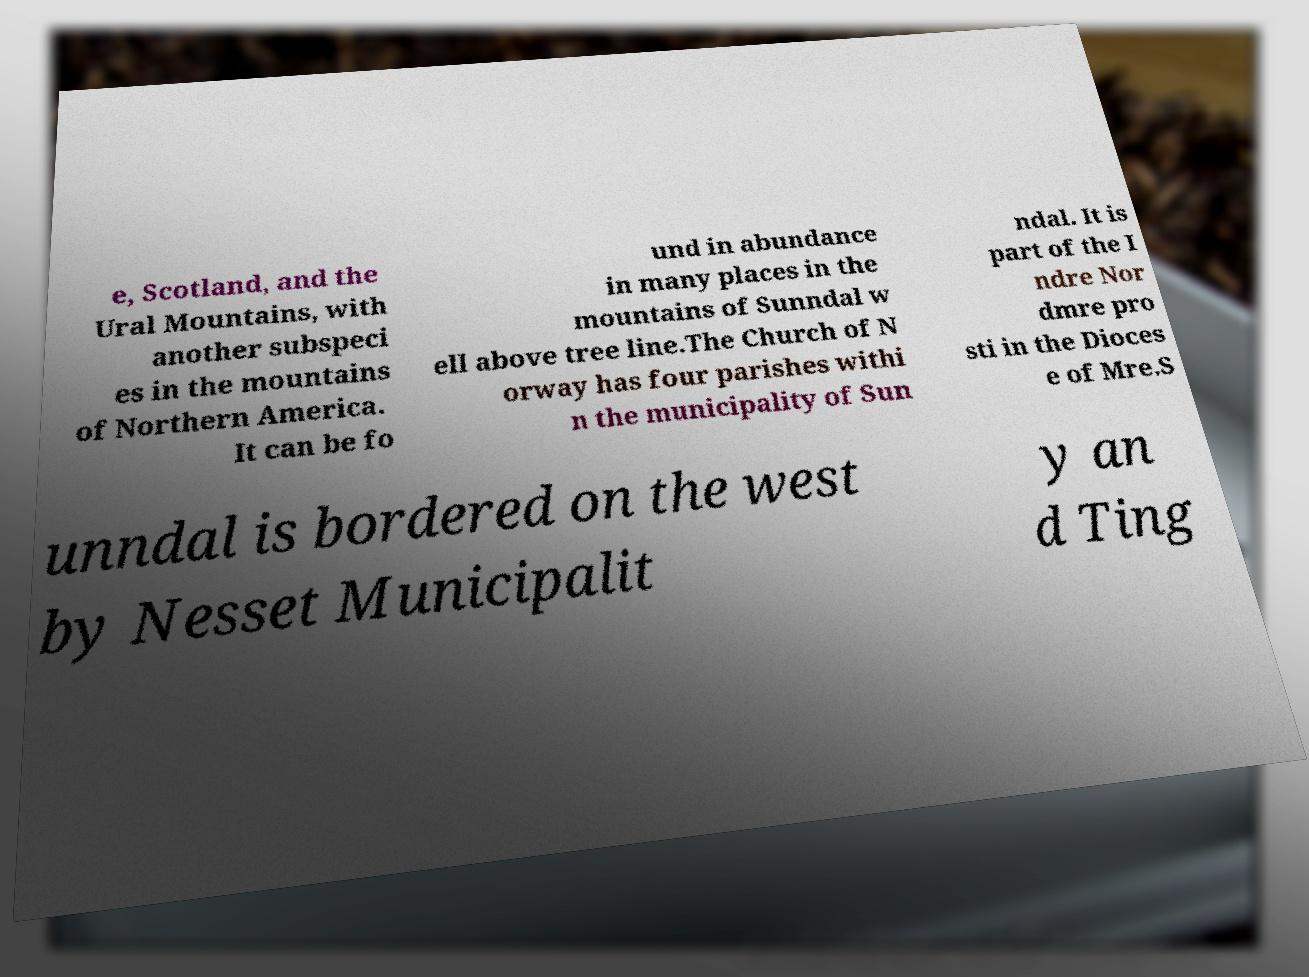Could you extract and type out the text from this image? e, Scotland, and the Ural Mountains, with another subspeci es in the mountains of Northern America. It can be fo und in abundance in many places in the mountains of Sunndal w ell above tree line.The Church of N orway has four parishes withi n the municipality of Sun ndal. It is part of the I ndre Nor dmre pro sti in the Dioces e of Mre.S unndal is bordered on the west by Nesset Municipalit y an d Ting 